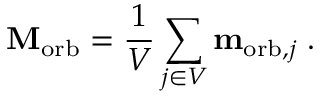Convert formula to latex. <formula><loc_0><loc_0><loc_500><loc_500>M _ { o r b } = { \frac { 1 } { V } } \sum _ { j \in V } m _ { { o r b } , j } \, .</formula> 